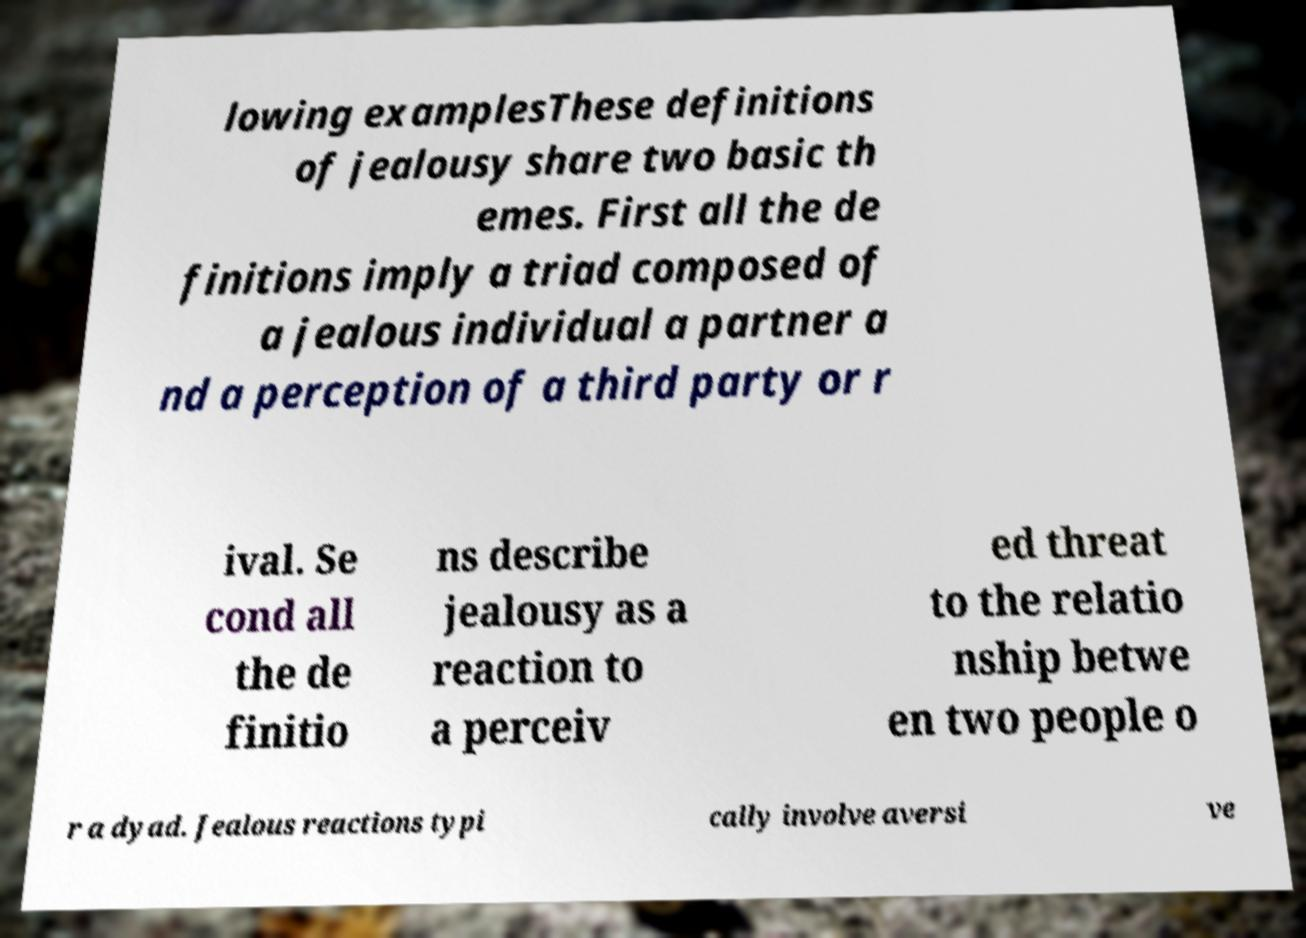Please identify and transcribe the text found in this image. lowing examplesThese definitions of jealousy share two basic th emes. First all the de finitions imply a triad composed of a jealous individual a partner a nd a perception of a third party or r ival. Se cond all the de finitio ns describe jealousy as a reaction to a perceiv ed threat to the relatio nship betwe en two people o r a dyad. Jealous reactions typi cally involve aversi ve 